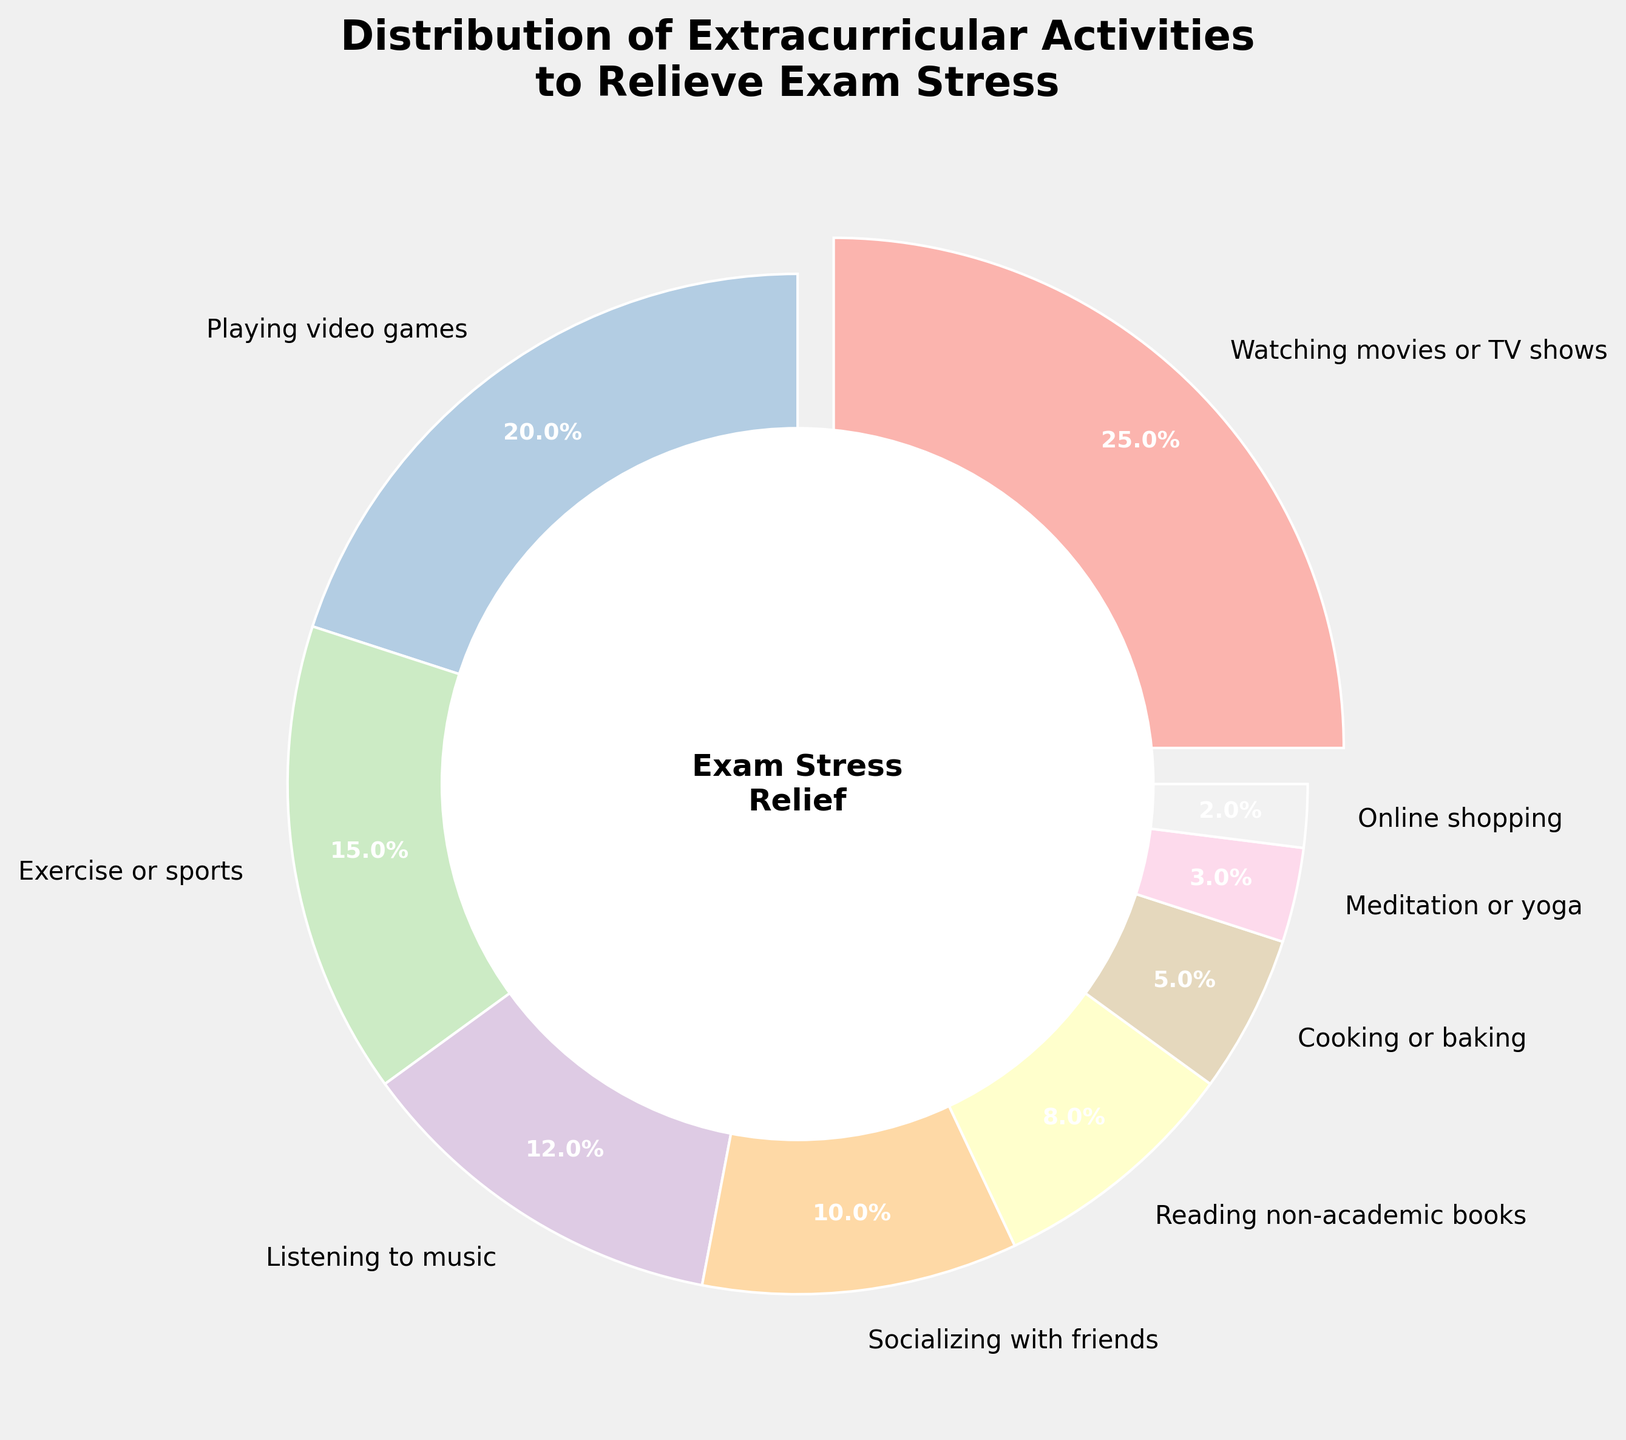Which activity has the highest percentage? The activity with the highest percentage is represented by the largest pie slice, which is highlighted by being slightly separated from the pie.
Answer: Watching movies or TV shows What is the combined percentage of 'Playing video games' and 'Exercise or sports'? The percentage for 'Playing video games' is 20%, and for 'Exercise or sports' is 15%. Adding them together gives 20% + 15% = 35%.
Answer: 35% Which activities have a lower percentage than 'Listening to music'? From the pie chart, 'Listening to music' has 12%. The activities with lower percentages are 'Socializing with friends' (10%), 'Reading non-academic books' (8%), 'Cooking or baking' (5%), 'Meditation or yoga' (3%), and 'Online shopping' (2%).
Answer: Socializing with friends, Reading non-academic books, Cooking or baking, Meditation or yoga, Online shopping By how much percentage is 'Watching movies or TV shows' greater than 'Cooking or baking'? The percentage for 'Watching movies or TV shows' is 25%, and for 'Cooking or baking' is 5%. The difference is 25% - 5% = 20%.
Answer: 20% What is the visual cue used to highlight the activity with the highest percentage? The visual cue used is an 'explosion' where the slice representing the activity is slightly separated from the rest of the pie chart.
Answer: Exploding slice Which activity has the smallest percentage? The smallest pie slice represents the activity with the lowest percentage, which is 2%.
Answer: Online shopping What percentage of students engage in 'Listening to music' and 'Socializing with friends' combined? 'Listening to music' is 12%, and 'Socializing with friends' is 10%. Adding these gives 12% + 10% = 22%.
Answer: 22% How many activities have a percentage less than 10%? Based on the pie chart, the activities with less than 10% are 'Reading non-academic books' (8%), 'Cooking or baking' (5%), 'Meditation or yoga' (3%), and 'Online shopping' (2%). Counting these gives 4 activities.
Answer: 4 What is the total percentage of all the activities represented in the chart? Adding all the percentages: 25% + 20% + 15% + 12% + 10% + 8% + 5% + 3% + 2% equals 100%.
Answer: 100% 